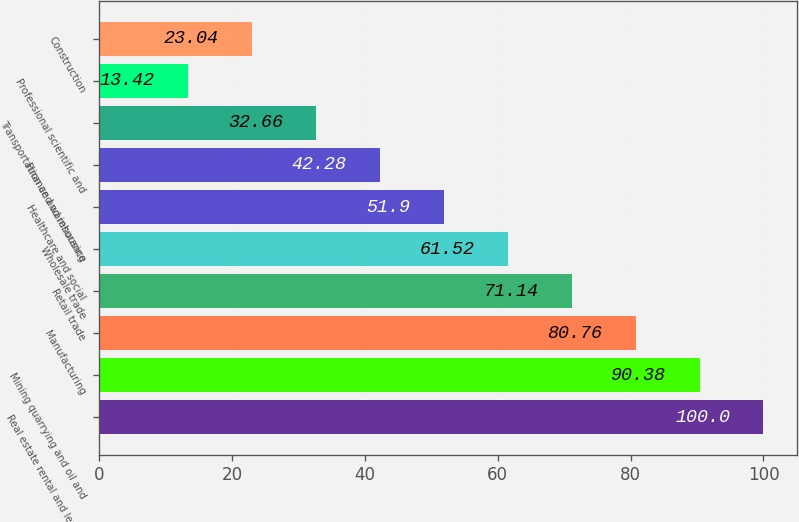Convert chart. <chart><loc_0><loc_0><loc_500><loc_500><bar_chart><fcel>Real estate rental and leasing<fcel>Mining quarrying and oil and<fcel>Manufacturing<fcel>Retail trade<fcel>Wholesale trade<fcel>Healthcare and social<fcel>Finance and insurance<fcel>Transportation and warehousing<fcel>Professional scientific and<fcel>Construction<nl><fcel>100<fcel>90.38<fcel>80.76<fcel>71.14<fcel>61.52<fcel>51.9<fcel>42.28<fcel>32.66<fcel>13.42<fcel>23.04<nl></chart> 